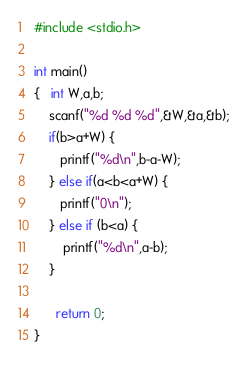<code> <loc_0><loc_0><loc_500><loc_500><_C_>#include <stdio.h>

int main()
{   int W,a,b;
    scanf("%d %d %d",&W,&a,&b);
    if(b>a+W) {
       printf("%d\n",b-a-W);
	} else if(a<b<a+W) {
	   printf("0\n");
	} else if (b<a) {
		printf("%d\n",a-b);
	}
	  
	  return 0;
}   </code> 